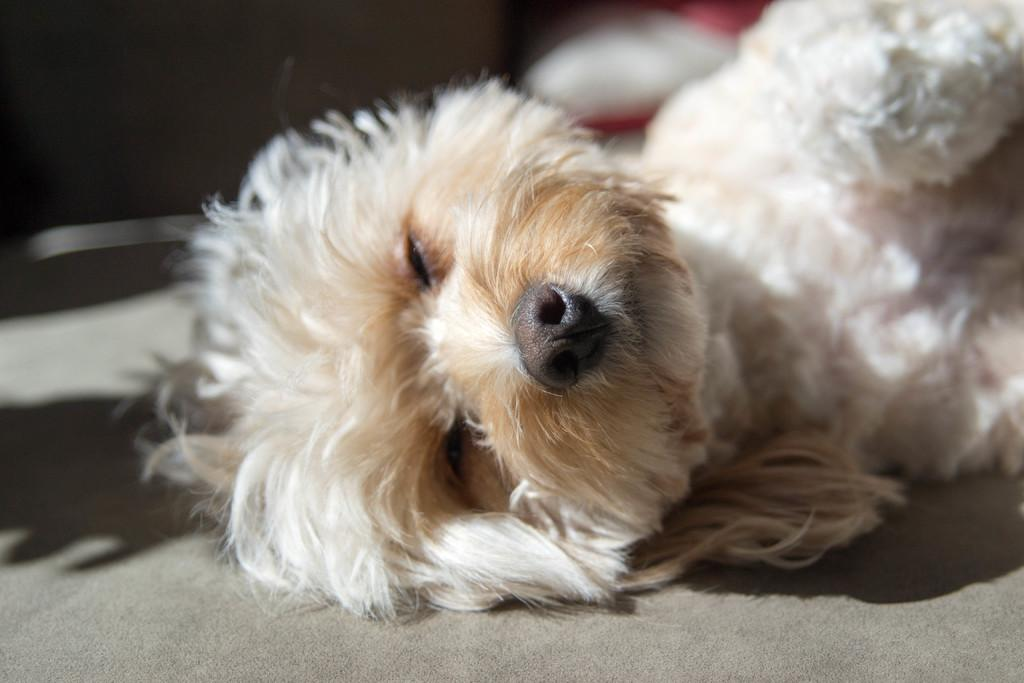What animal is present in the image? There is a dog in the image. What is the dog doing in the image? The dog is laying on the floor. What type of desk can be seen in the aftermath of the dog's actions in the image? There is no desk present in the image, and the dog's actions do not suggest any aftermath. 